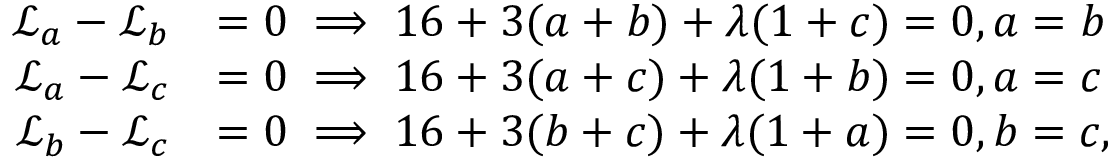Convert formula to latex. <formula><loc_0><loc_0><loc_500><loc_500>\begin{array} { r l } { \mathcal { L } _ { a } - \mathcal { L } _ { b } } & { = 0 \implies 1 6 + 3 ( a + b ) + \lambda ( 1 + c ) = 0 , a = b } \\ { \mathcal { L } _ { a } - \mathcal { L } _ { c } } & { = 0 \implies 1 6 + 3 ( a + c ) + \lambda ( 1 + b ) = 0 , a = c } \\ { \mathcal { L } _ { b } - \mathcal { L } _ { c } } & { = 0 \implies 1 6 + 3 ( b + c ) + \lambda ( 1 + a ) = 0 , b = c , } \end{array}</formula> 